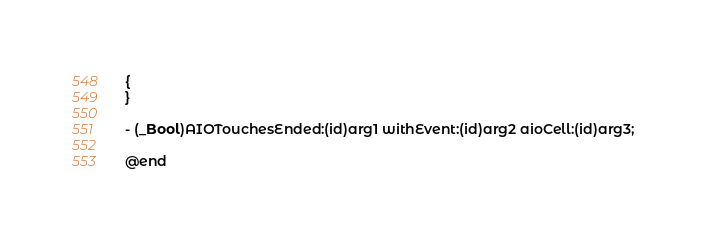Convert code to text. <code><loc_0><loc_0><loc_500><loc_500><_C_>{
}

- (_Bool)AIOTouchesEnded:(id)arg1 withEvent:(id)arg2 aioCell:(id)arg3;

@end

</code> 